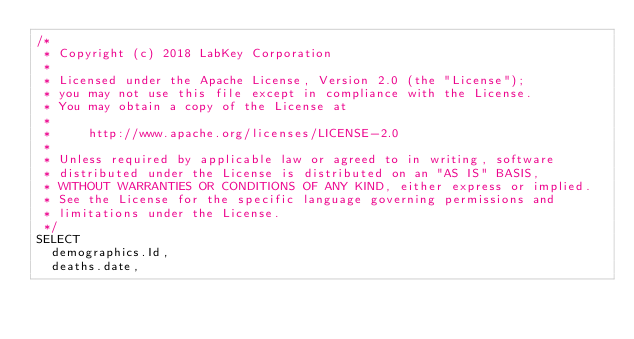<code> <loc_0><loc_0><loc_500><loc_500><_SQL_>/*
 * Copyright (c) 2018 LabKey Corporation
 *
 * Licensed under the Apache License, Version 2.0 (the "License");
 * you may not use this file except in compliance with the License.
 * You may obtain a copy of the License at
 *
 *     http://www.apache.org/licenses/LICENSE-2.0
 *
 * Unless required by applicable law or agreed to in writing, software
 * distributed under the License is distributed on an "AS IS" BASIS,
 * WITHOUT WARRANTIES OR CONDITIONS OF ANY KIND, either express or implied.
 * See the License for the specific language governing permissions and
 * limitations under the License.
 */
SELECT
  demographics.Id,
  deaths.date,</code> 